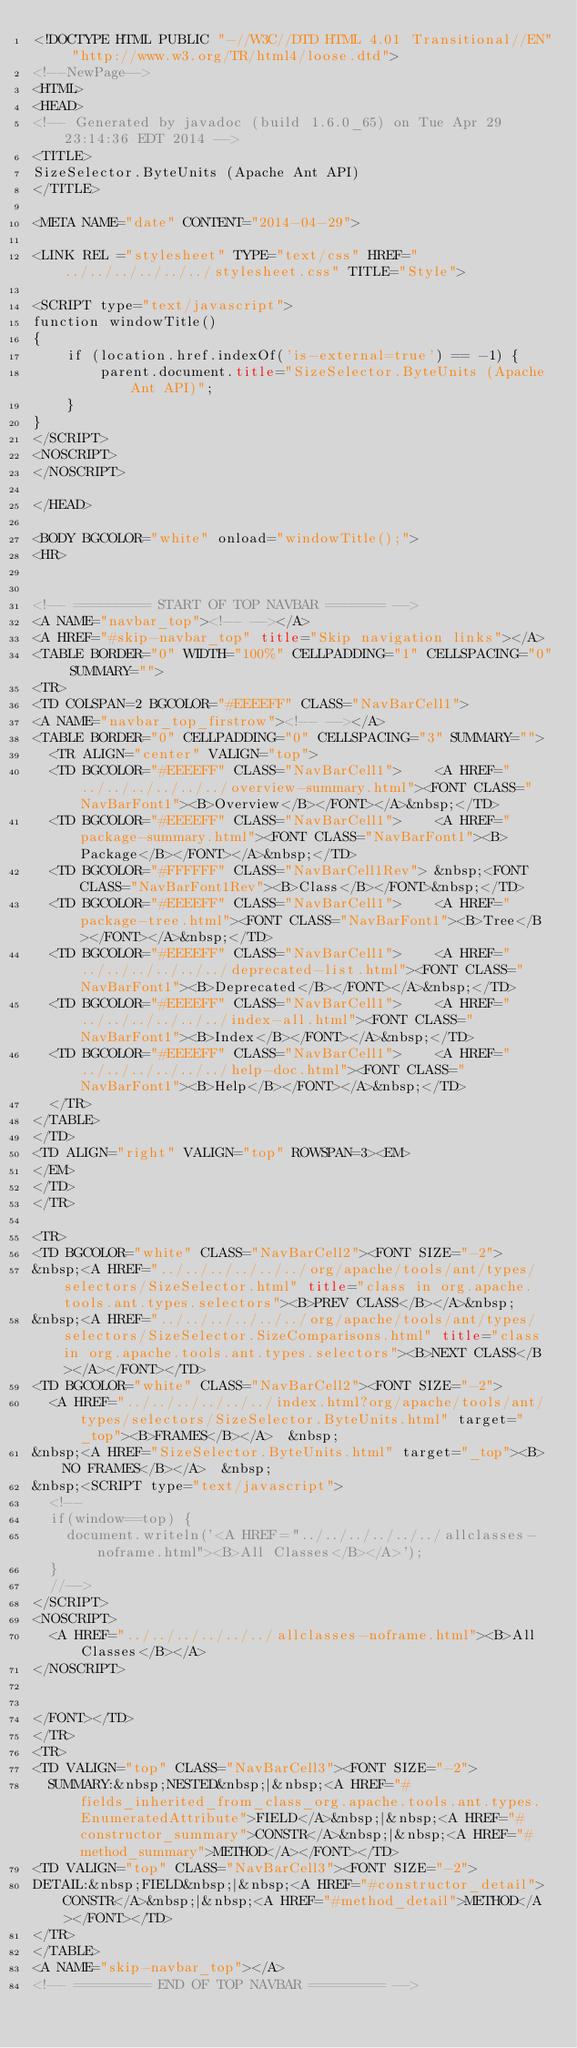Convert code to text. <code><loc_0><loc_0><loc_500><loc_500><_HTML_><!DOCTYPE HTML PUBLIC "-//W3C//DTD HTML 4.01 Transitional//EN" "http://www.w3.org/TR/html4/loose.dtd">
<!--NewPage-->
<HTML>
<HEAD>
<!-- Generated by javadoc (build 1.6.0_65) on Tue Apr 29 23:14:36 EDT 2014 -->
<TITLE>
SizeSelector.ByteUnits (Apache Ant API)
</TITLE>

<META NAME="date" CONTENT="2014-04-29">

<LINK REL ="stylesheet" TYPE="text/css" HREF="../../../../../../stylesheet.css" TITLE="Style">

<SCRIPT type="text/javascript">
function windowTitle()
{
    if (location.href.indexOf('is-external=true') == -1) {
        parent.document.title="SizeSelector.ByteUnits (Apache Ant API)";
    }
}
</SCRIPT>
<NOSCRIPT>
</NOSCRIPT>

</HEAD>

<BODY BGCOLOR="white" onload="windowTitle();">
<HR>


<!-- ========= START OF TOP NAVBAR ======= -->
<A NAME="navbar_top"><!-- --></A>
<A HREF="#skip-navbar_top" title="Skip navigation links"></A>
<TABLE BORDER="0" WIDTH="100%" CELLPADDING="1" CELLSPACING="0" SUMMARY="">
<TR>
<TD COLSPAN=2 BGCOLOR="#EEEEFF" CLASS="NavBarCell1">
<A NAME="navbar_top_firstrow"><!-- --></A>
<TABLE BORDER="0" CELLPADDING="0" CELLSPACING="3" SUMMARY="">
  <TR ALIGN="center" VALIGN="top">
  <TD BGCOLOR="#EEEEFF" CLASS="NavBarCell1">    <A HREF="../../../../../../overview-summary.html"><FONT CLASS="NavBarFont1"><B>Overview</B></FONT></A>&nbsp;</TD>
  <TD BGCOLOR="#EEEEFF" CLASS="NavBarCell1">    <A HREF="package-summary.html"><FONT CLASS="NavBarFont1"><B>Package</B></FONT></A>&nbsp;</TD>
  <TD BGCOLOR="#FFFFFF" CLASS="NavBarCell1Rev"> &nbsp;<FONT CLASS="NavBarFont1Rev"><B>Class</B></FONT>&nbsp;</TD>
  <TD BGCOLOR="#EEEEFF" CLASS="NavBarCell1">    <A HREF="package-tree.html"><FONT CLASS="NavBarFont1"><B>Tree</B></FONT></A>&nbsp;</TD>
  <TD BGCOLOR="#EEEEFF" CLASS="NavBarCell1">    <A HREF="../../../../../../deprecated-list.html"><FONT CLASS="NavBarFont1"><B>Deprecated</B></FONT></A>&nbsp;</TD>
  <TD BGCOLOR="#EEEEFF" CLASS="NavBarCell1">    <A HREF="../../../../../../index-all.html"><FONT CLASS="NavBarFont1"><B>Index</B></FONT></A>&nbsp;</TD>
  <TD BGCOLOR="#EEEEFF" CLASS="NavBarCell1">    <A HREF="../../../../../../help-doc.html"><FONT CLASS="NavBarFont1"><B>Help</B></FONT></A>&nbsp;</TD>
  </TR>
</TABLE>
</TD>
<TD ALIGN="right" VALIGN="top" ROWSPAN=3><EM>
</EM>
</TD>
</TR>

<TR>
<TD BGCOLOR="white" CLASS="NavBarCell2"><FONT SIZE="-2">
&nbsp;<A HREF="../../../../../../org/apache/tools/ant/types/selectors/SizeSelector.html" title="class in org.apache.tools.ant.types.selectors"><B>PREV CLASS</B></A>&nbsp;
&nbsp;<A HREF="../../../../../../org/apache/tools/ant/types/selectors/SizeSelector.SizeComparisons.html" title="class in org.apache.tools.ant.types.selectors"><B>NEXT CLASS</B></A></FONT></TD>
<TD BGCOLOR="white" CLASS="NavBarCell2"><FONT SIZE="-2">
  <A HREF="../../../../../../index.html?org/apache/tools/ant/types/selectors/SizeSelector.ByteUnits.html" target="_top"><B>FRAMES</B></A>  &nbsp;
&nbsp;<A HREF="SizeSelector.ByteUnits.html" target="_top"><B>NO FRAMES</B></A>  &nbsp;
&nbsp;<SCRIPT type="text/javascript">
  <!--
  if(window==top) {
    document.writeln('<A HREF="../../../../../../allclasses-noframe.html"><B>All Classes</B></A>');
  }
  //-->
</SCRIPT>
<NOSCRIPT>
  <A HREF="../../../../../../allclasses-noframe.html"><B>All Classes</B></A>
</NOSCRIPT>


</FONT></TD>
</TR>
<TR>
<TD VALIGN="top" CLASS="NavBarCell3"><FONT SIZE="-2">
  SUMMARY:&nbsp;NESTED&nbsp;|&nbsp;<A HREF="#fields_inherited_from_class_org.apache.tools.ant.types.EnumeratedAttribute">FIELD</A>&nbsp;|&nbsp;<A HREF="#constructor_summary">CONSTR</A>&nbsp;|&nbsp;<A HREF="#method_summary">METHOD</A></FONT></TD>
<TD VALIGN="top" CLASS="NavBarCell3"><FONT SIZE="-2">
DETAIL:&nbsp;FIELD&nbsp;|&nbsp;<A HREF="#constructor_detail">CONSTR</A>&nbsp;|&nbsp;<A HREF="#method_detail">METHOD</A></FONT></TD>
</TR>
</TABLE>
<A NAME="skip-navbar_top"></A>
<!-- ========= END OF TOP NAVBAR ========= -->
</code> 